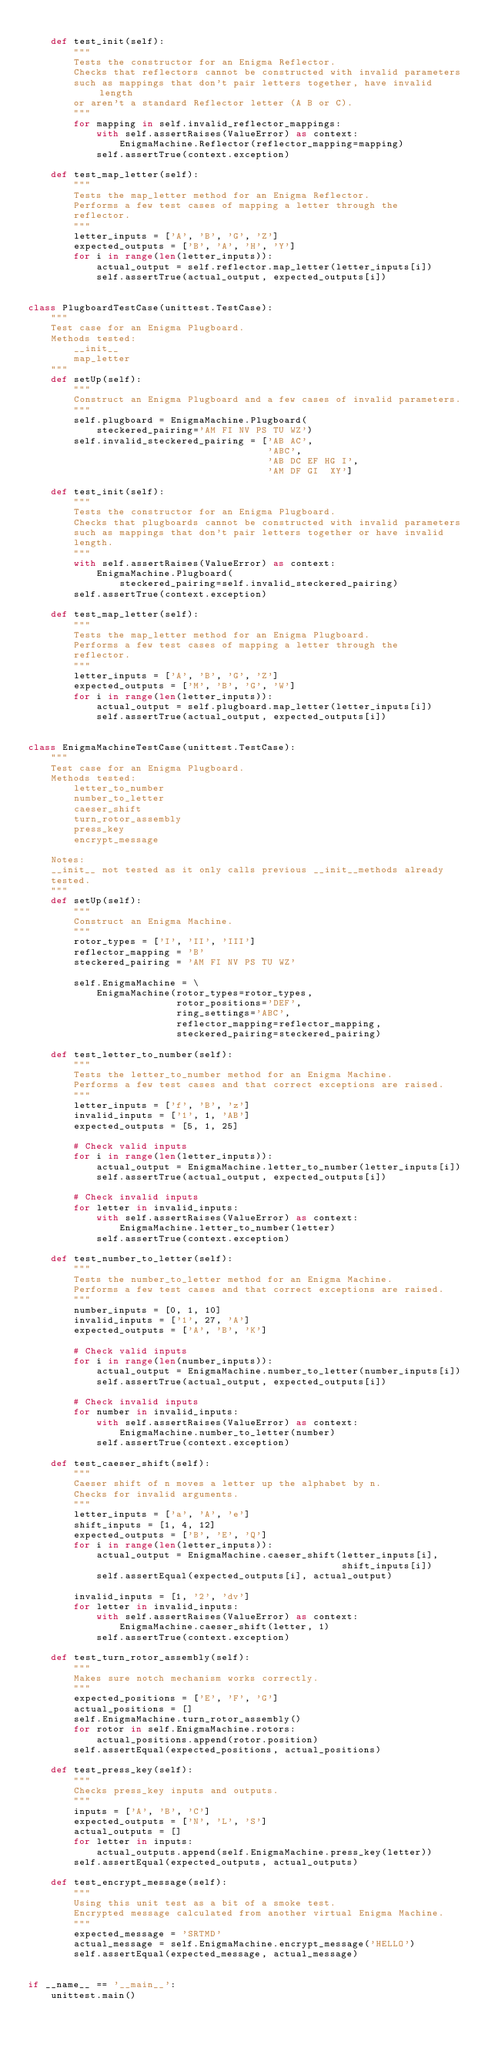<code> <loc_0><loc_0><loc_500><loc_500><_Python_>
    def test_init(self):
        """
        Tests the constructor for an Enigma Reflector.
        Checks that reflectors cannot be constructed with invalid parameters
        such as mappings that don't pair letters together, have invalid length
        or aren't a standard Reflector letter (A B or C).
        """
        for mapping in self.invalid_reflector_mappings:
            with self.assertRaises(ValueError) as context:
                EnigmaMachine.Reflector(reflector_mapping=mapping)
            self.assertTrue(context.exception)

    def test_map_letter(self):
        """
        Tests the map_letter method for an Enigma Reflector.
        Performs a few test cases of mapping a letter through the
        reflector.
        """
        letter_inputs = ['A', 'B', 'G', 'Z']
        expected_outputs = ['B', 'A', 'H', 'Y']
        for i in range(len(letter_inputs)):
            actual_output = self.reflector.map_letter(letter_inputs[i])
            self.assertTrue(actual_output, expected_outputs[i])


class PlugboardTestCase(unittest.TestCase):
    """
    Test case for an Enigma Plugboard.
    Methods tested:
        __init__
        map_letter
    """
    def setUp(self):
        """
        Construct an Enigma Plugboard and a few cases of invalid parameters.
        """
        self.plugboard = EnigmaMachine.Plugboard(
            steckered_pairing='AM FI NV PS TU WZ')
        self.invalid_steckered_pairing = ['AB AC',
                                          'ABC',
                                          'AB DC EF HG I',
                                          'AM DF GI  XY']

    def test_init(self):
        """
        Tests the constructor for an Enigma Plugboard.
        Checks that plugboards cannot be constructed with invalid parameters
        such as mappings that don't pair letters together or have invalid
        length.
        """
        with self.assertRaises(ValueError) as context:
            EnigmaMachine.Plugboard(
                steckered_pairing=self.invalid_steckered_pairing)
        self.assertTrue(context.exception)

    def test_map_letter(self):
        """
        Tests the map_letter method for an Enigma Plugboard.
        Performs a few test cases of mapping a letter through the
        reflector.
        """
        letter_inputs = ['A', 'B', 'G', 'Z']
        expected_outputs = ['M', 'B', 'G', 'W']
        for i in range(len(letter_inputs)):
            actual_output = self.plugboard.map_letter(letter_inputs[i])
            self.assertTrue(actual_output, expected_outputs[i])


class EnigmaMachineTestCase(unittest.TestCase):
    """
    Test case for an Enigma Plugboard.
    Methods tested:
        letter_to_number
        number_to_letter
        caeser_shift
        turn_rotor_assembly
        press_key
        encrypt_message

    Notes:
    __init__ not tested as it only calls previous __init__methods already
    tested.
    """
    def setUp(self):
        """
        Construct an Enigma Machine.
        """
        rotor_types = ['I', 'II', 'III']
        reflector_mapping = 'B'
        steckered_pairing = 'AM FI NV PS TU WZ'

        self.EnigmaMachine = \
            EnigmaMachine(rotor_types=rotor_types,
                          rotor_positions='DEF',
                          ring_settings='ABC',
                          reflector_mapping=reflector_mapping,
                          steckered_pairing=steckered_pairing)

    def test_letter_to_number(self):
        """
        Tests the letter_to_number method for an Enigma Machine.
        Performs a few test cases and that correct exceptions are raised.
        """
        letter_inputs = ['f', 'B', 'z']
        invalid_inputs = ['1', 1, 'AB']
        expected_outputs = [5, 1, 25]

        # Check valid inputs
        for i in range(len(letter_inputs)):
            actual_output = EnigmaMachine.letter_to_number(letter_inputs[i])
            self.assertTrue(actual_output, expected_outputs[i])

        # Check invalid inputs
        for letter in invalid_inputs:
            with self.assertRaises(ValueError) as context:
                EnigmaMachine.letter_to_number(letter)
            self.assertTrue(context.exception)

    def test_number_to_letter(self):
        """
        Tests the number_to_letter method for an Enigma Machine.
        Performs a few test cases and that correct exceptions are raised.
        """
        number_inputs = [0, 1, 10]
        invalid_inputs = ['1', 27, 'A']
        expected_outputs = ['A', 'B', 'K']

        # Check valid inputs
        for i in range(len(number_inputs)):
            actual_output = EnigmaMachine.number_to_letter(number_inputs[i])
            self.assertTrue(actual_output, expected_outputs[i])

        # Check invalid inputs
        for number in invalid_inputs:
            with self.assertRaises(ValueError) as context:
                EnigmaMachine.number_to_letter(number)
            self.assertTrue(context.exception)

    def test_caeser_shift(self):
        """
        Caeser shift of n moves a letter up the alphabet by n.
        Checks for invalid arguments.
        """
        letter_inputs = ['a', 'A', 'e']
        shift_inputs = [1, 4, 12]
        expected_outputs = ['B', 'E', 'Q']
        for i in range(len(letter_inputs)):
            actual_output = EnigmaMachine.caeser_shift(letter_inputs[i],
                                                       shift_inputs[i])
            self.assertEqual(expected_outputs[i], actual_output)

        invalid_inputs = [1, '2', 'dv']
        for letter in invalid_inputs:
            with self.assertRaises(ValueError) as context:
                EnigmaMachine.caeser_shift(letter, 1)
            self.assertTrue(context.exception)

    def test_turn_rotor_assembly(self):
        """
        Makes sure notch mechanism works correctly.
        """
        expected_positions = ['E', 'F', 'G']
        actual_positions = []
        self.EnigmaMachine.turn_rotor_assembly()
        for rotor in self.EnigmaMachine.rotors:
            actual_positions.append(rotor.position)
        self.assertEqual(expected_positions, actual_positions)

    def test_press_key(self):
        """
        Checks press_key inputs and outputs.
        """
        inputs = ['A', 'B', 'C']
        expected_outputs = ['N', 'L', 'S']
        actual_outputs = []
        for letter in inputs:
            actual_outputs.append(self.EnigmaMachine.press_key(letter))
        self.assertEqual(expected_outputs, actual_outputs)

    def test_encrypt_message(self):
        """
        Using this unit test as a bit of a smoke test.
        Encrypted message calculated from another virtual Enigma Machine.
        """
        expected_message = 'SRTMD'
        actual_message = self.EnigmaMachine.encrypt_message('HELLO')
        self.assertEqual(expected_message, actual_message)


if __name__ == '__main__':
    unittest.main()
</code> 